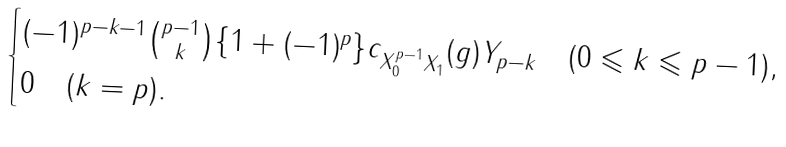Convert formula to latex. <formula><loc_0><loc_0><loc_500><loc_500>\begin{cases} ( - 1 ) ^ { p - k - 1 } \binom { p - 1 } { k } \{ 1 + ( - 1 ) ^ { p } \} c _ { X _ { 0 } ^ { p - 1 } X _ { 1 } } ( g ) Y _ { p - k } \quad ( 0 \leqslant k \leqslant p - 1 ) , \\ 0 \quad ( k = p ) . \\ \end{cases}</formula> 